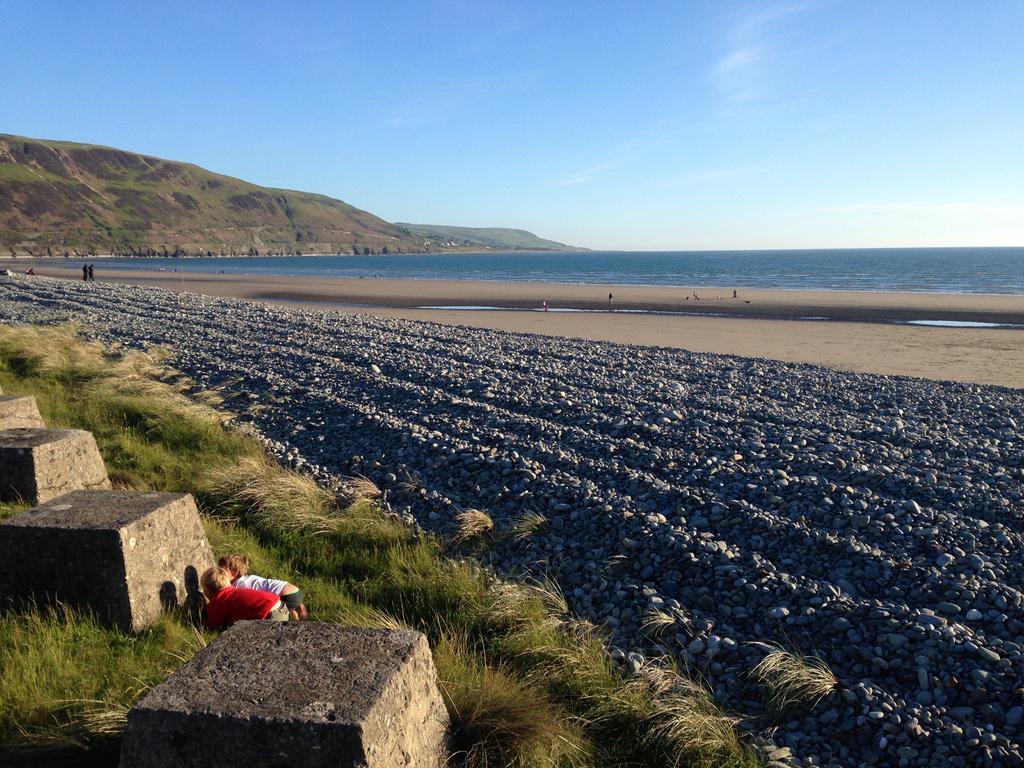Could you give a brief overview of what you see in this image? In this image we can see a group of stones. On the left side, we can see two persons, rocks and the grass. Behind the stones we can see persons, mountains and the water. At the top we can see the sky. 